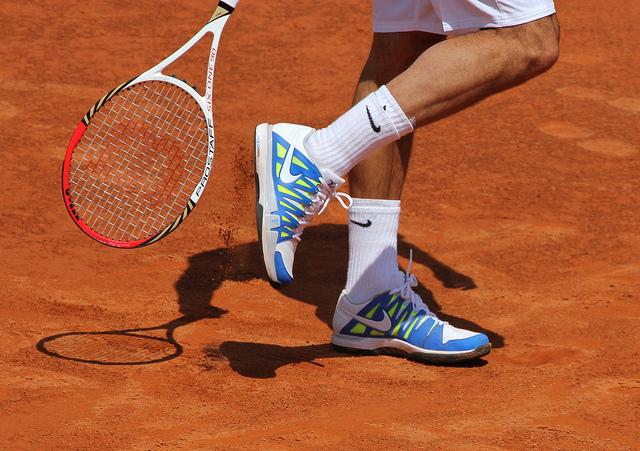What brand of shoes is the person wearing?
Concise answer only. Nike. What is the ground made of?
Short answer required. Clay. Are his socks the same brand as his shoes?
Give a very brief answer. Yes. 